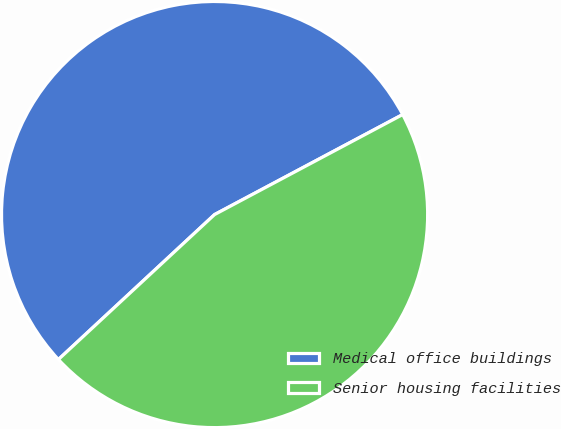Convert chart. <chart><loc_0><loc_0><loc_500><loc_500><pie_chart><fcel>Medical office buildings<fcel>Senior housing facilities<nl><fcel>54.13%<fcel>45.87%<nl></chart> 